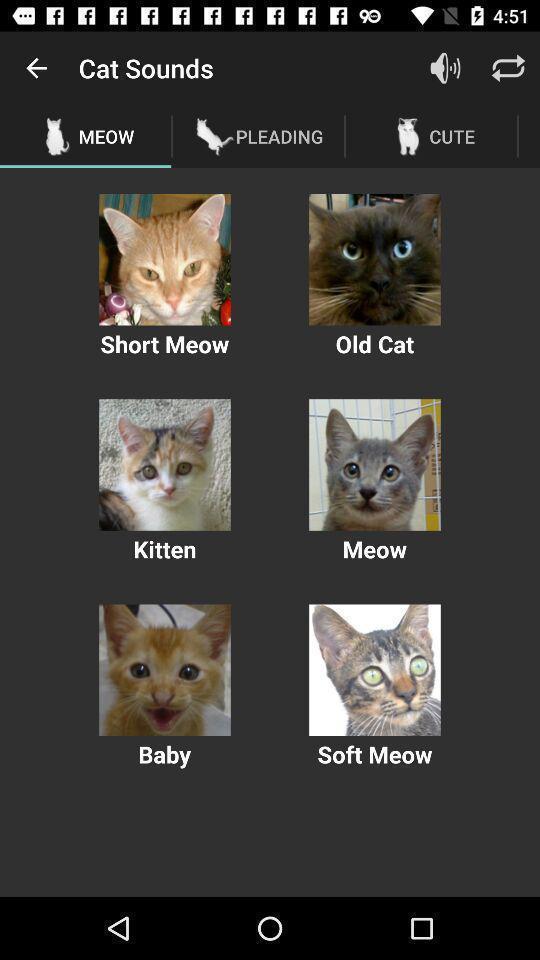Tell me about the visual elements in this screen capture. Screen displaying various cat images. 